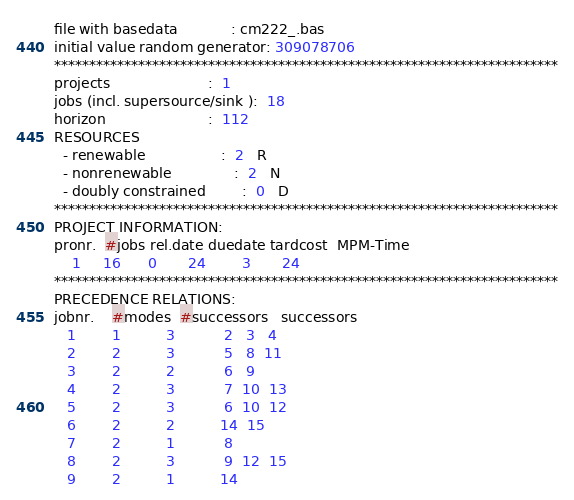Convert code to text. <code><loc_0><loc_0><loc_500><loc_500><_ObjectiveC_>file with basedata            : cm222_.bas
initial value random generator: 309078706
************************************************************************
projects                      :  1
jobs (incl. supersource/sink ):  18
horizon                       :  112
RESOURCES
  - renewable                 :  2   R
  - nonrenewable              :  2   N
  - doubly constrained        :  0   D
************************************************************************
PROJECT INFORMATION:
pronr.  #jobs rel.date duedate tardcost  MPM-Time
    1     16      0       24        3       24
************************************************************************
PRECEDENCE RELATIONS:
jobnr.    #modes  #successors   successors
   1        1          3           2   3   4
   2        2          3           5   8  11
   3        2          2           6   9
   4        2          3           7  10  13
   5        2          3           6  10  12
   6        2          2          14  15
   7        2          1           8
   8        2          3           9  12  15
   9        2          1          14</code> 